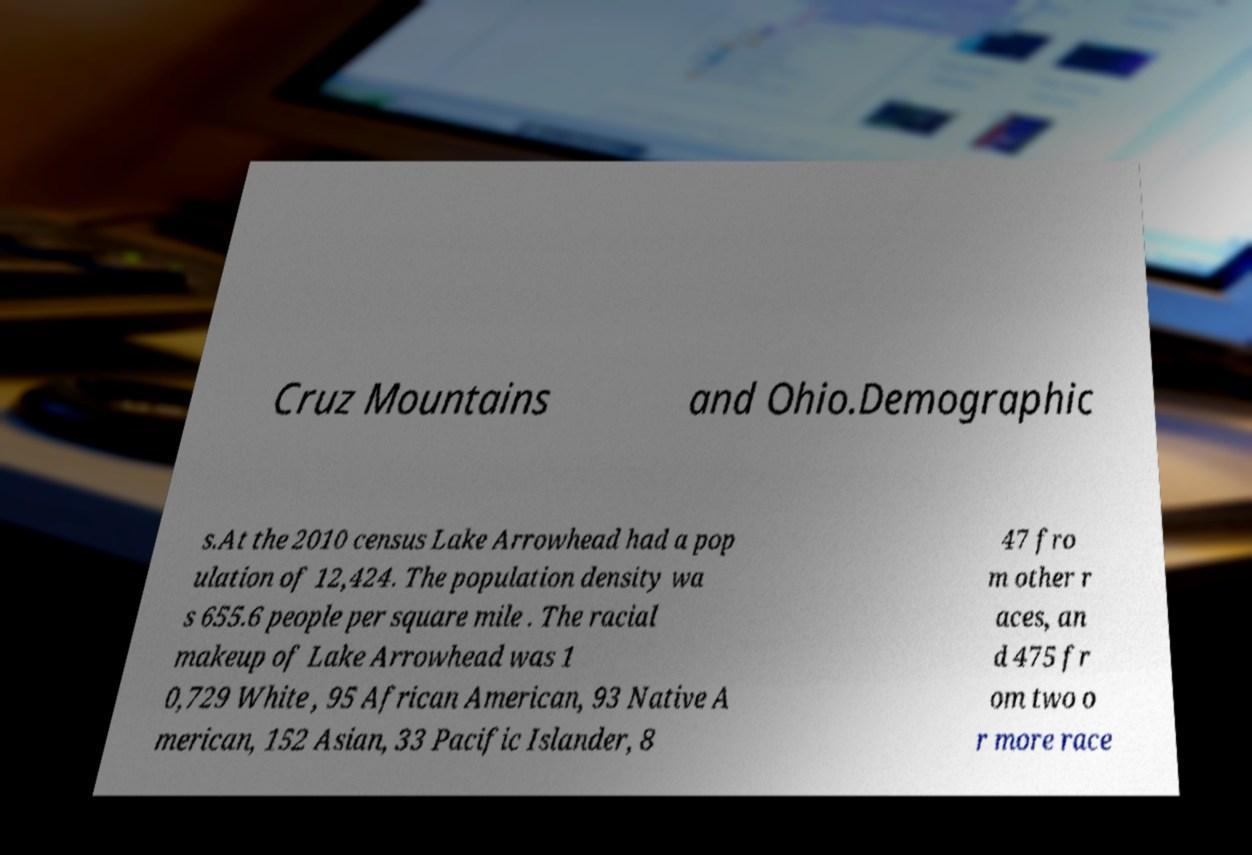Can you read and provide the text displayed in the image?This photo seems to have some interesting text. Can you extract and type it out for me? Cruz Mountains and Ohio.Demographic s.At the 2010 census Lake Arrowhead had a pop ulation of 12,424. The population density wa s 655.6 people per square mile . The racial makeup of Lake Arrowhead was 1 0,729 White , 95 African American, 93 Native A merican, 152 Asian, 33 Pacific Islander, 8 47 fro m other r aces, an d 475 fr om two o r more race 